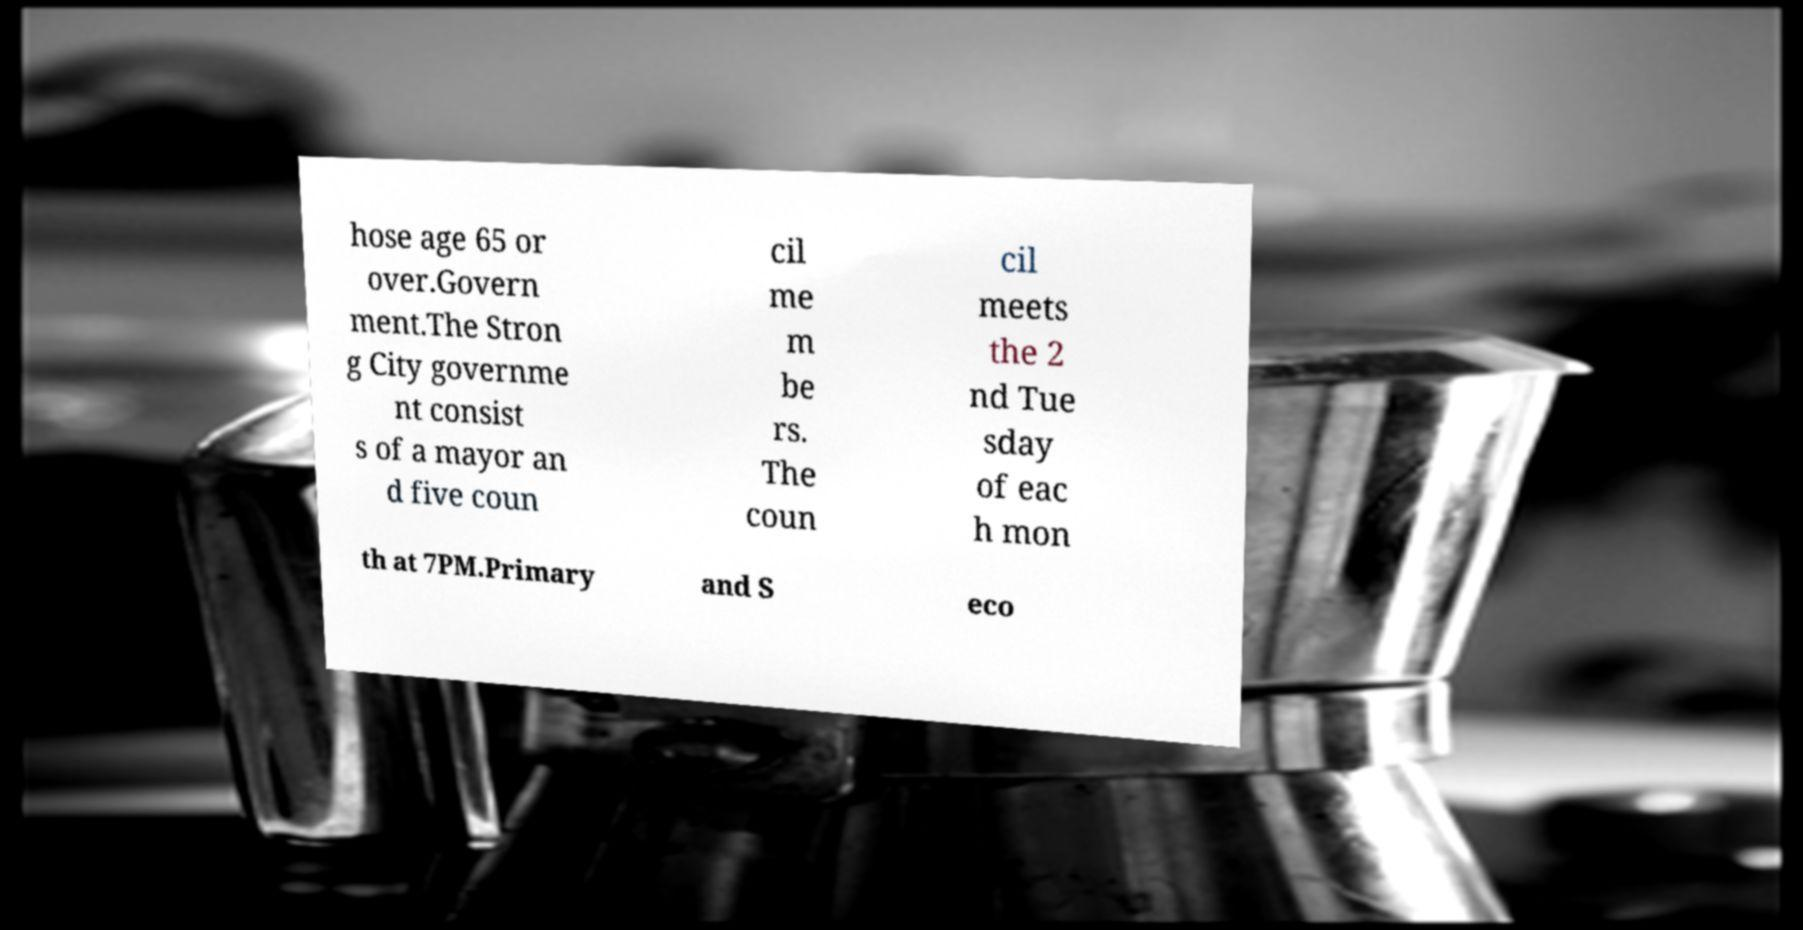There's text embedded in this image that I need extracted. Can you transcribe it verbatim? hose age 65 or over.Govern ment.The Stron g City governme nt consist s of a mayor an d five coun cil me m be rs. The coun cil meets the 2 nd Tue sday of eac h mon th at 7PM.Primary and S eco 